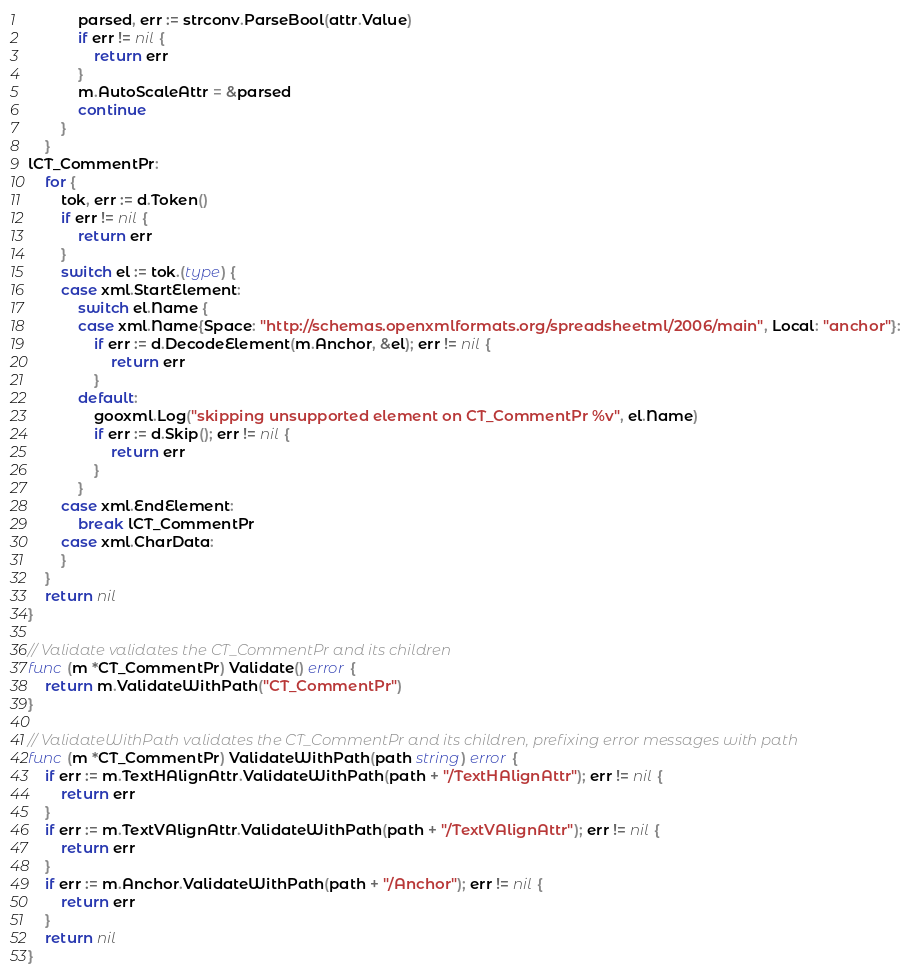Convert code to text. <code><loc_0><loc_0><loc_500><loc_500><_Go_>			parsed, err := strconv.ParseBool(attr.Value)
			if err != nil {
				return err
			}
			m.AutoScaleAttr = &parsed
			continue
		}
	}
lCT_CommentPr:
	for {
		tok, err := d.Token()
		if err != nil {
			return err
		}
		switch el := tok.(type) {
		case xml.StartElement:
			switch el.Name {
			case xml.Name{Space: "http://schemas.openxmlformats.org/spreadsheetml/2006/main", Local: "anchor"}:
				if err := d.DecodeElement(m.Anchor, &el); err != nil {
					return err
				}
			default:
				gooxml.Log("skipping unsupported element on CT_CommentPr %v", el.Name)
				if err := d.Skip(); err != nil {
					return err
				}
			}
		case xml.EndElement:
			break lCT_CommentPr
		case xml.CharData:
		}
	}
	return nil
}

// Validate validates the CT_CommentPr and its children
func (m *CT_CommentPr) Validate() error {
	return m.ValidateWithPath("CT_CommentPr")
}

// ValidateWithPath validates the CT_CommentPr and its children, prefixing error messages with path
func (m *CT_CommentPr) ValidateWithPath(path string) error {
	if err := m.TextHAlignAttr.ValidateWithPath(path + "/TextHAlignAttr"); err != nil {
		return err
	}
	if err := m.TextVAlignAttr.ValidateWithPath(path + "/TextVAlignAttr"); err != nil {
		return err
	}
	if err := m.Anchor.ValidateWithPath(path + "/Anchor"); err != nil {
		return err
	}
	return nil
}
</code> 